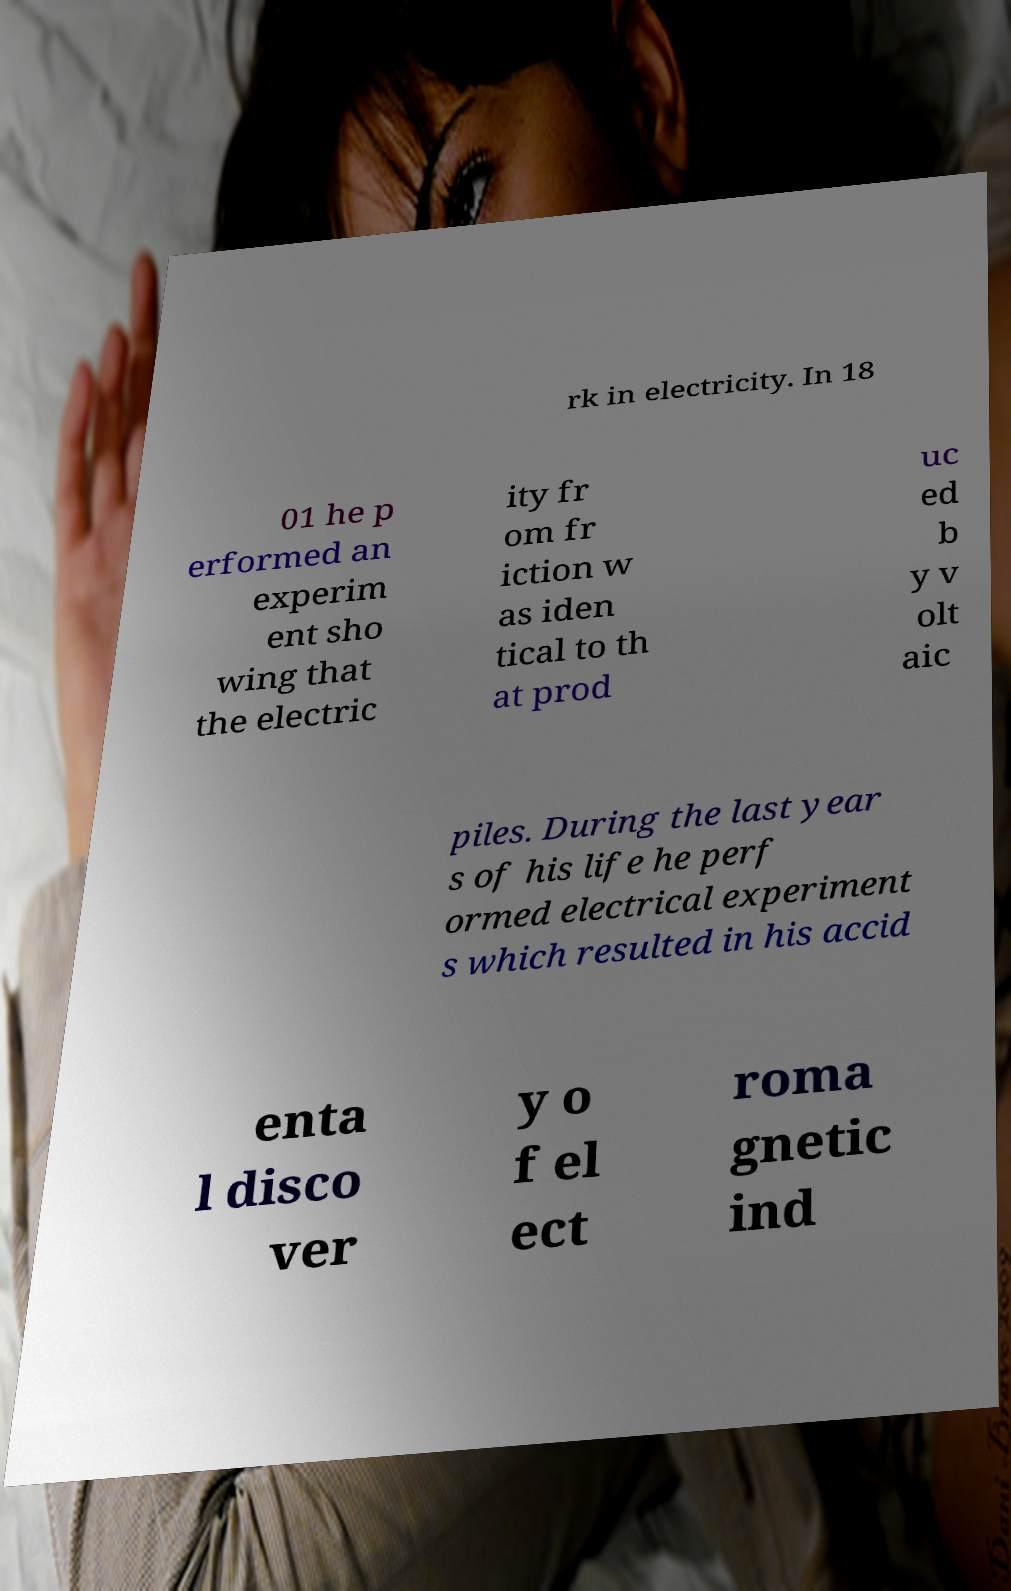What messages or text are displayed in this image? I need them in a readable, typed format. rk in electricity. In 18 01 he p erformed an experim ent sho wing that the electric ity fr om fr iction w as iden tical to th at prod uc ed b y v olt aic piles. During the last year s of his life he perf ormed electrical experiment s which resulted in his accid enta l disco ver y o f el ect roma gnetic ind 